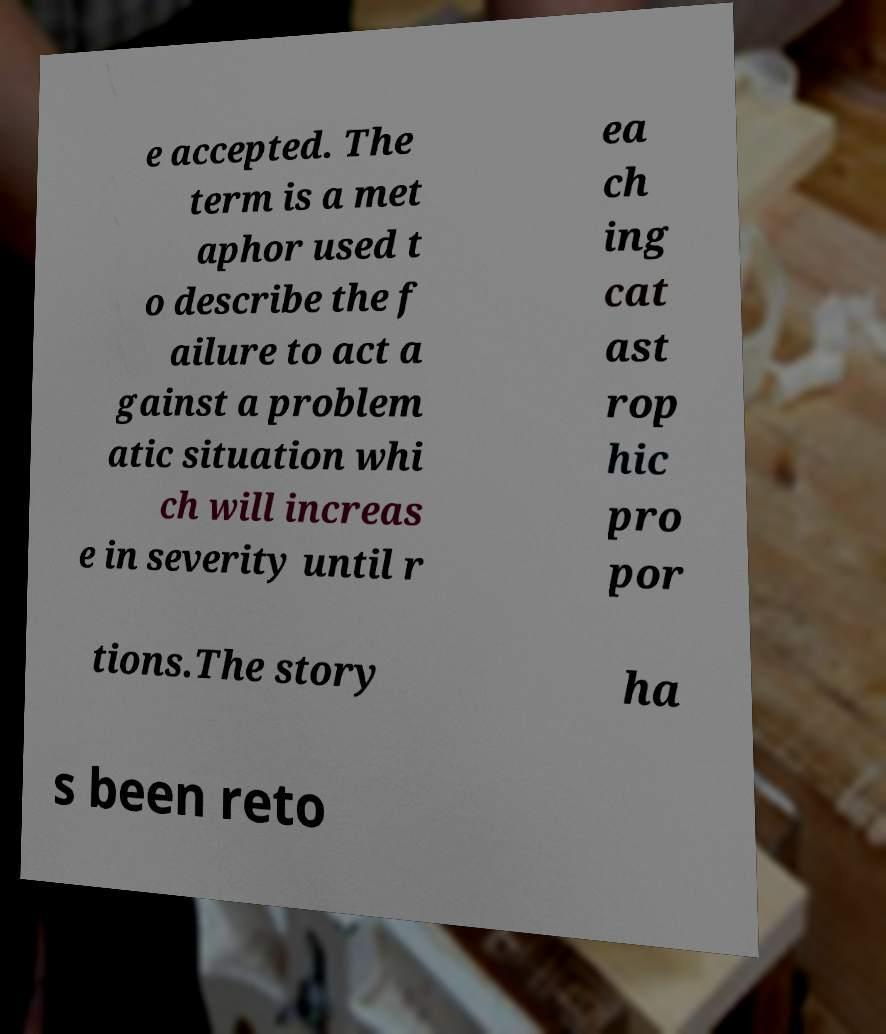What messages or text are displayed in this image? I need them in a readable, typed format. e accepted. The term is a met aphor used t o describe the f ailure to act a gainst a problem atic situation whi ch will increas e in severity until r ea ch ing cat ast rop hic pro por tions.The story ha s been reto 